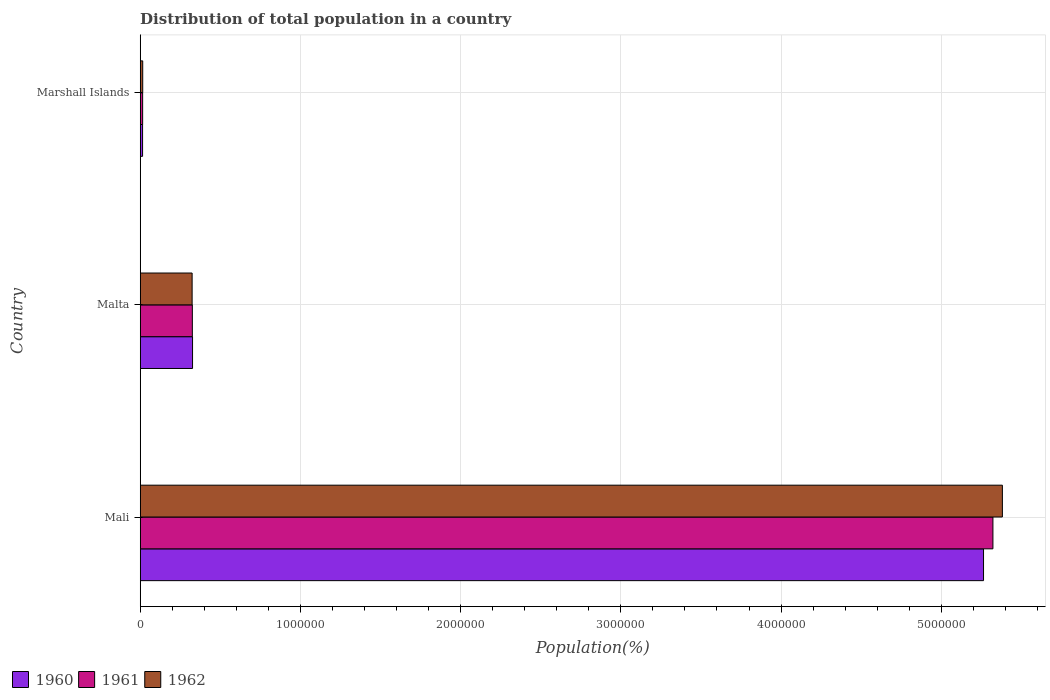How many bars are there on the 3rd tick from the top?
Give a very brief answer. 3. What is the label of the 1st group of bars from the top?
Your response must be concise. Marshall Islands. In how many cases, is the number of bars for a given country not equal to the number of legend labels?
Make the answer very short. 0. What is the population of in 1961 in Mali?
Ensure brevity in your answer.  5.32e+06. Across all countries, what is the maximum population of in 1961?
Provide a short and direct response. 5.32e+06. Across all countries, what is the minimum population of in 1962?
Your response must be concise. 1.55e+04. In which country was the population of in 1961 maximum?
Give a very brief answer. Mali. In which country was the population of in 1960 minimum?
Your response must be concise. Marshall Islands. What is the total population of in 1960 in the graph?
Your response must be concise. 5.60e+06. What is the difference between the population of in 1962 in Mali and that in Malta?
Your answer should be compact. 5.06e+06. What is the difference between the population of in 1962 in Marshall Islands and the population of in 1961 in Malta?
Provide a short and direct response. -3.10e+05. What is the average population of in 1962 per country?
Offer a terse response. 1.91e+06. What is the difference between the population of in 1961 and population of in 1962 in Mali?
Provide a succinct answer. -5.91e+04. What is the ratio of the population of in 1962 in Mali to that in Malta?
Keep it short and to the point. 16.61. Is the difference between the population of in 1961 in Malta and Marshall Islands greater than the difference between the population of in 1962 in Malta and Marshall Islands?
Keep it short and to the point. Yes. What is the difference between the highest and the second highest population of in 1961?
Your response must be concise. 5.00e+06. What is the difference between the highest and the lowest population of in 1960?
Offer a very short reply. 5.25e+06. Is the sum of the population of in 1961 in Mali and Marshall Islands greater than the maximum population of in 1962 across all countries?
Your response must be concise. No. What does the 2nd bar from the top in Malta represents?
Provide a succinct answer. 1961. How many bars are there?
Keep it short and to the point. 9. Are all the bars in the graph horizontal?
Ensure brevity in your answer.  Yes. How many countries are there in the graph?
Keep it short and to the point. 3. What is the difference between two consecutive major ticks on the X-axis?
Keep it short and to the point. 1.00e+06. Does the graph contain any zero values?
Ensure brevity in your answer.  No. Where does the legend appear in the graph?
Offer a terse response. Bottom left. How are the legend labels stacked?
Your answer should be compact. Horizontal. What is the title of the graph?
Give a very brief answer. Distribution of total population in a country. What is the label or title of the X-axis?
Give a very brief answer. Population(%). What is the label or title of the Y-axis?
Provide a short and direct response. Country. What is the Population(%) in 1960 in Mali?
Give a very brief answer. 5.26e+06. What is the Population(%) of 1961 in Mali?
Your answer should be very brief. 5.32e+06. What is the Population(%) of 1962 in Mali?
Offer a terse response. 5.38e+06. What is the Population(%) of 1960 in Malta?
Offer a very short reply. 3.27e+05. What is the Population(%) in 1961 in Malta?
Ensure brevity in your answer.  3.25e+05. What is the Population(%) in 1962 in Malta?
Your response must be concise. 3.24e+05. What is the Population(%) of 1960 in Marshall Islands?
Keep it short and to the point. 1.47e+04. What is the Population(%) in 1961 in Marshall Islands?
Keep it short and to the point. 1.51e+04. What is the Population(%) of 1962 in Marshall Islands?
Provide a succinct answer. 1.55e+04. Across all countries, what is the maximum Population(%) of 1960?
Provide a succinct answer. 5.26e+06. Across all countries, what is the maximum Population(%) in 1961?
Provide a succinct answer. 5.32e+06. Across all countries, what is the maximum Population(%) in 1962?
Your answer should be compact. 5.38e+06. Across all countries, what is the minimum Population(%) of 1960?
Your answer should be very brief. 1.47e+04. Across all countries, what is the minimum Population(%) of 1961?
Make the answer very short. 1.51e+04. Across all countries, what is the minimum Population(%) of 1962?
Provide a short and direct response. 1.55e+04. What is the total Population(%) in 1960 in the graph?
Your answer should be compact. 5.60e+06. What is the total Population(%) of 1961 in the graph?
Provide a succinct answer. 5.66e+06. What is the total Population(%) in 1962 in the graph?
Keep it short and to the point. 5.72e+06. What is the difference between the Population(%) in 1960 in Mali and that in Malta?
Your response must be concise. 4.94e+06. What is the difference between the Population(%) in 1961 in Mali and that in Malta?
Keep it short and to the point. 5.00e+06. What is the difference between the Population(%) of 1962 in Mali and that in Malta?
Offer a terse response. 5.06e+06. What is the difference between the Population(%) of 1960 in Mali and that in Marshall Islands?
Keep it short and to the point. 5.25e+06. What is the difference between the Population(%) in 1961 in Mali and that in Marshall Islands?
Keep it short and to the point. 5.31e+06. What is the difference between the Population(%) in 1962 in Mali and that in Marshall Islands?
Provide a succinct answer. 5.37e+06. What is the difference between the Population(%) in 1960 in Malta and that in Marshall Islands?
Your answer should be very brief. 3.12e+05. What is the difference between the Population(%) of 1961 in Malta and that in Marshall Islands?
Your response must be concise. 3.10e+05. What is the difference between the Population(%) in 1962 in Malta and that in Marshall Islands?
Your answer should be very brief. 3.08e+05. What is the difference between the Population(%) in 1960 in Mali and the Population(%) in 1961 in Malta?
Ensure brevity in your answer.  4.94e+06. What is the difference between the Population(%) of 1960 in Mali and the Population(%) of 1962 in Malta?
Make the answer very short. 4.94e+06. What is the difference between the Population(%) in 1961 in Mali and the Population(%) in 1962 in Malta?
Your answer should be very brief. 5.00e+06. What is the difference between the Population(%) in 1960 in Mali and the Population(%) in 1961 in Marshall Islands?
Your answer should be compact. 5.25e+06. What is the difference between the Population(%) in 1960 in Mali and the Population(%) in 1962 in Marshall Islands?
Offer a terse response. 5.25e+06. What is the difference between the Population(%) in 1961 in Mali and the Population(%) in 1962 in Marshall Islands?
Provide a short and direct response. 5.31e+06. What is the difference between the Population(%) in 1960 in Malta and the Population(%) in 1961 in Marshall Islands?
Give a very brief answer. 3.11e+05. What is the difference between the Population(%) in 1960 in Malta and the Population(%) in 1962 in Marshall Islands?
Your answer should be very brief. 3.11e+05. What is the difference between the Population(%) in 1961 in Malta and the Population(%) in 1962 in Marshall Islands?
Your response must be concise. 3.10e+05. What is the average Population(%) in 1960 per country?
Offer a terse response. 1.87e+06. What is the average Population(%) of 1961 per country?
Offer a terse response. 1.89e+06. What is the average Population(%) of 1962 per country?
Your response must be concise. 1.91e+06. What is the difference between the Population(%) in 1960 and Population(%) in 1961 in Mali?
Provide a short and direct response. -5.85e+04. What is the difference between the Population(%) of 1960 and Population(%) of 1962 in Mali?
Your response must be concise. -1.18e+05. What is the difference between the Population(%) in 1961 and Population(%) in 1962 in Mali?
Your response must be concise. -5.91e+04. What is the difference between the Population(%) of 1960 and Population(%) of 1961 in Malta?
Your answer should be compact. 1300. What is the difference between the Population(%) in 1960 and Population(%) in 1962 in Malta?
Offer a very short reply. 2650. What is the difference between the Population(%) of 1961 and Population(%) of 1962 in Malta?
Provide a short and direct response. 1350. What is the difference between the Population(%) in 1960 and Population(%) in 1961 in Marshall Islands?
Give a very brief answer. -387. What is the difference between the Population(%) in 1960 and Population(%) in 1962 in Marshall Islands?
Your response must be concise. -880. What is the difference between the Population(%) of 1961 and Population(%) of 1962 in Marshall Islands?
Offer a terse response. -493. What is the ratio of the Population(%) in 1960 in Mali to that in Malta?
Your answer should be compact. 16.12. What is the ratio of the Population(%) of 1961 in Mali to that in Malta?
Make the answer very short. 16.36. What is the ratio of the Population(%) of 1962 in Mali to that in Malta?
Offer a very short reply. 16.61. What is the ratio of the Population(%) of 1960 in Mali to that in Marshall Islands?
Provide a short and direct response. 358.93. What is the ratio of the Population(%) in 1961 in Mali to that in Marshall Islands?
Ensure brevity in your answer.  353.59. What is the ratio of the Population(%) in 1962 in Mali to that in Marshall Islands?
Offer a terse response. 346.18. What is the ratio of the Population(%) of 1960 in Malta to that in Marshall Islands?
Provide a succinct answer. 22.27. What is the ratio of the Population(%) of 1961 in Malta to that in Marshall Islands?
Make the answer very short. 21.61. What is the ratio of the Population(%) in 1962 in Malta to that in Marshall Islands?
Offer a terse response. 20.84. What is the difference between the highest and the second highest Population(%) in 1960?
Your answer should be very brief. 4.94e+06. What is the difference between the highest and the second highest Population(%) in 1961?
Your answer should be very brief. 5.00e+06. What is the difference between the highest and the second highest Population(%) in 1962?
Offer a terse response. 5.06e+06. What is the difference between the highest and the lowest Population(%) of 1960?
Offer a very short reply. 5.25e+06. What is the difference between the highest and the lowest Population(%) of 1961?
Provide a short and direct response. 5.31e+06. What is the difference between the highest and the lowest Population(%) of 1962?
Keep it short and to the point. 5.37e+06. 